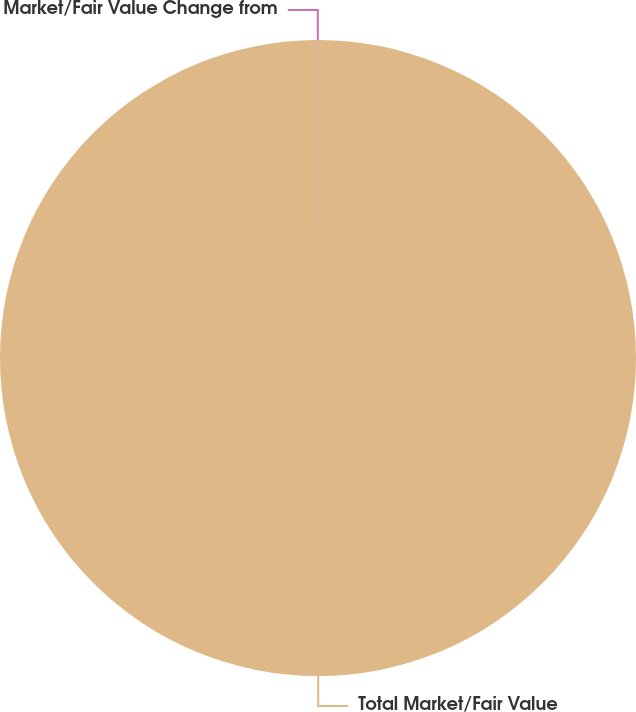<chart> <loc_0><loc_0><loc_500><loc_500><pie_chart><fcel>Total Market/Fair Value<fcel>Market/Fair Value Change from<nl><fcel>99.98%<fcel>0.02%<nl></chart> 